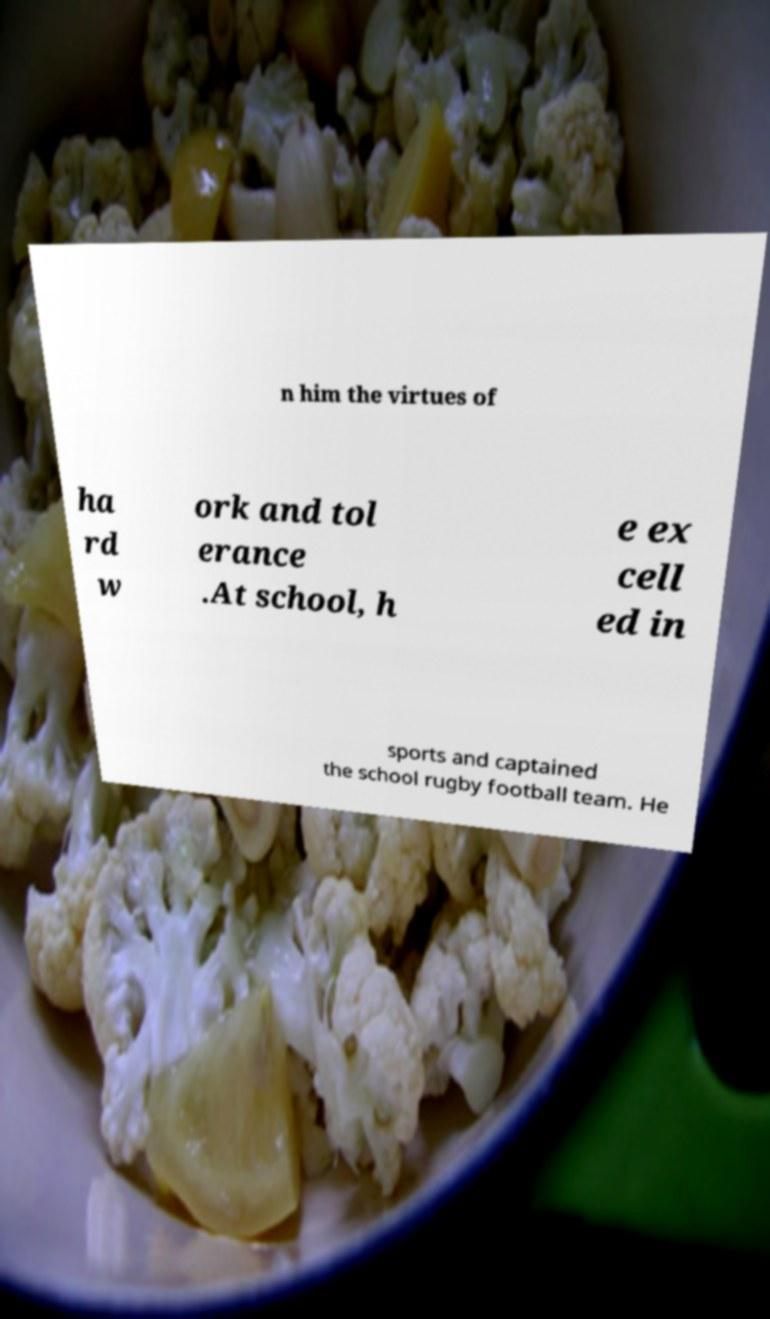Can you read and provide the text displayed in the image?This photo seems to have some interesting text. Can you extract and type it out for me? n him the virtues of ha rd w ork and tol erance .At school, h e ex cell ed in sports and captained the school rugby football team. He 